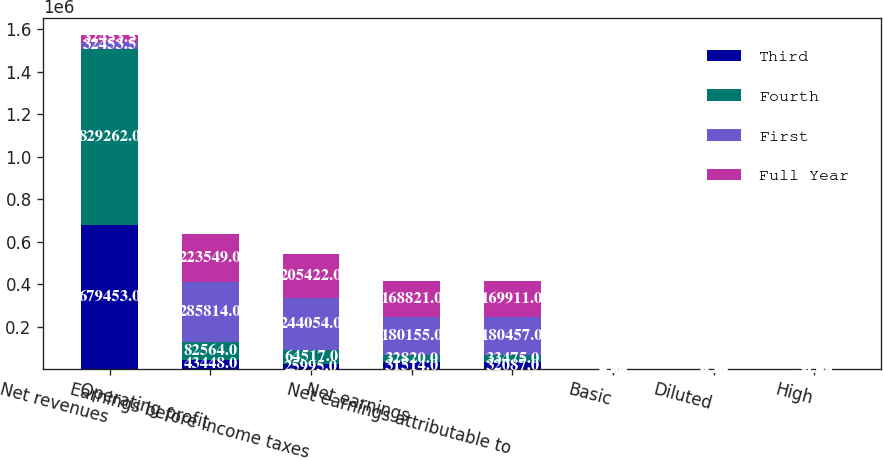<chart> <loc_0><loc_0><loc_500><loc_500><stacked_bar_chart><ecel><fcel>Net revenues<fcel>Operating profit<fcel>Earnings before income taxes<fcel>Net earnings<fcel>Net earnings attributable to<fcel>Basic<fcel>Diluted<fcel>High<nl><fcel>Third<fcel>679453<fcel>43448<fcel>25995<fcel>31514<fcel>32087<fcel>0.24<fcel>0.24<fcel>55.67<nl><fcel>Fourth<fcel>829262<fcel>82564<fcel>64517<fcel>32820<fcel>33475<fcel>0.26<fcel>0.26<fcel>56.91<nl><fcel>First<fcel>32453.5<fcel>285814<fcel>244054<fcel>180155<fcel>180457<fcel>1.42<fcel>1.4<fcel>55.78<nl><fcel>Full Year<fcel>32453.5<fcel>223549<fcel>205422<fcel>168821<fcel>169911<fcel>1.35<fcel>1.34<fcel>59.42<nl></chart> 